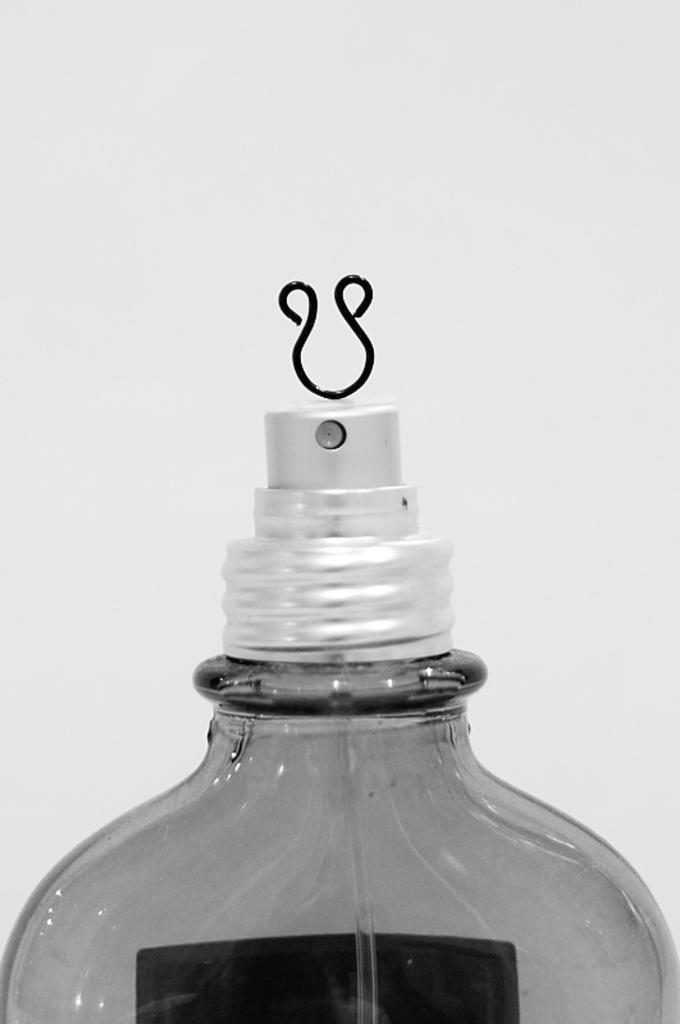What object is visible in the image? There is a spray bottle in the image. Where is the spray bottle located in the image? The spray bottle is placed over a surface. What feature can be seen at the top of the spray bottle? There is a pin present at the top of the spray bottle. How many bells are attached to the spray bottle in the image? There are no bells attached to the spray bottle in the image. What angle is the spray bottle positioned at in the image? The angle at which the spray bottle is positioned cannot be determined from the image alone. 